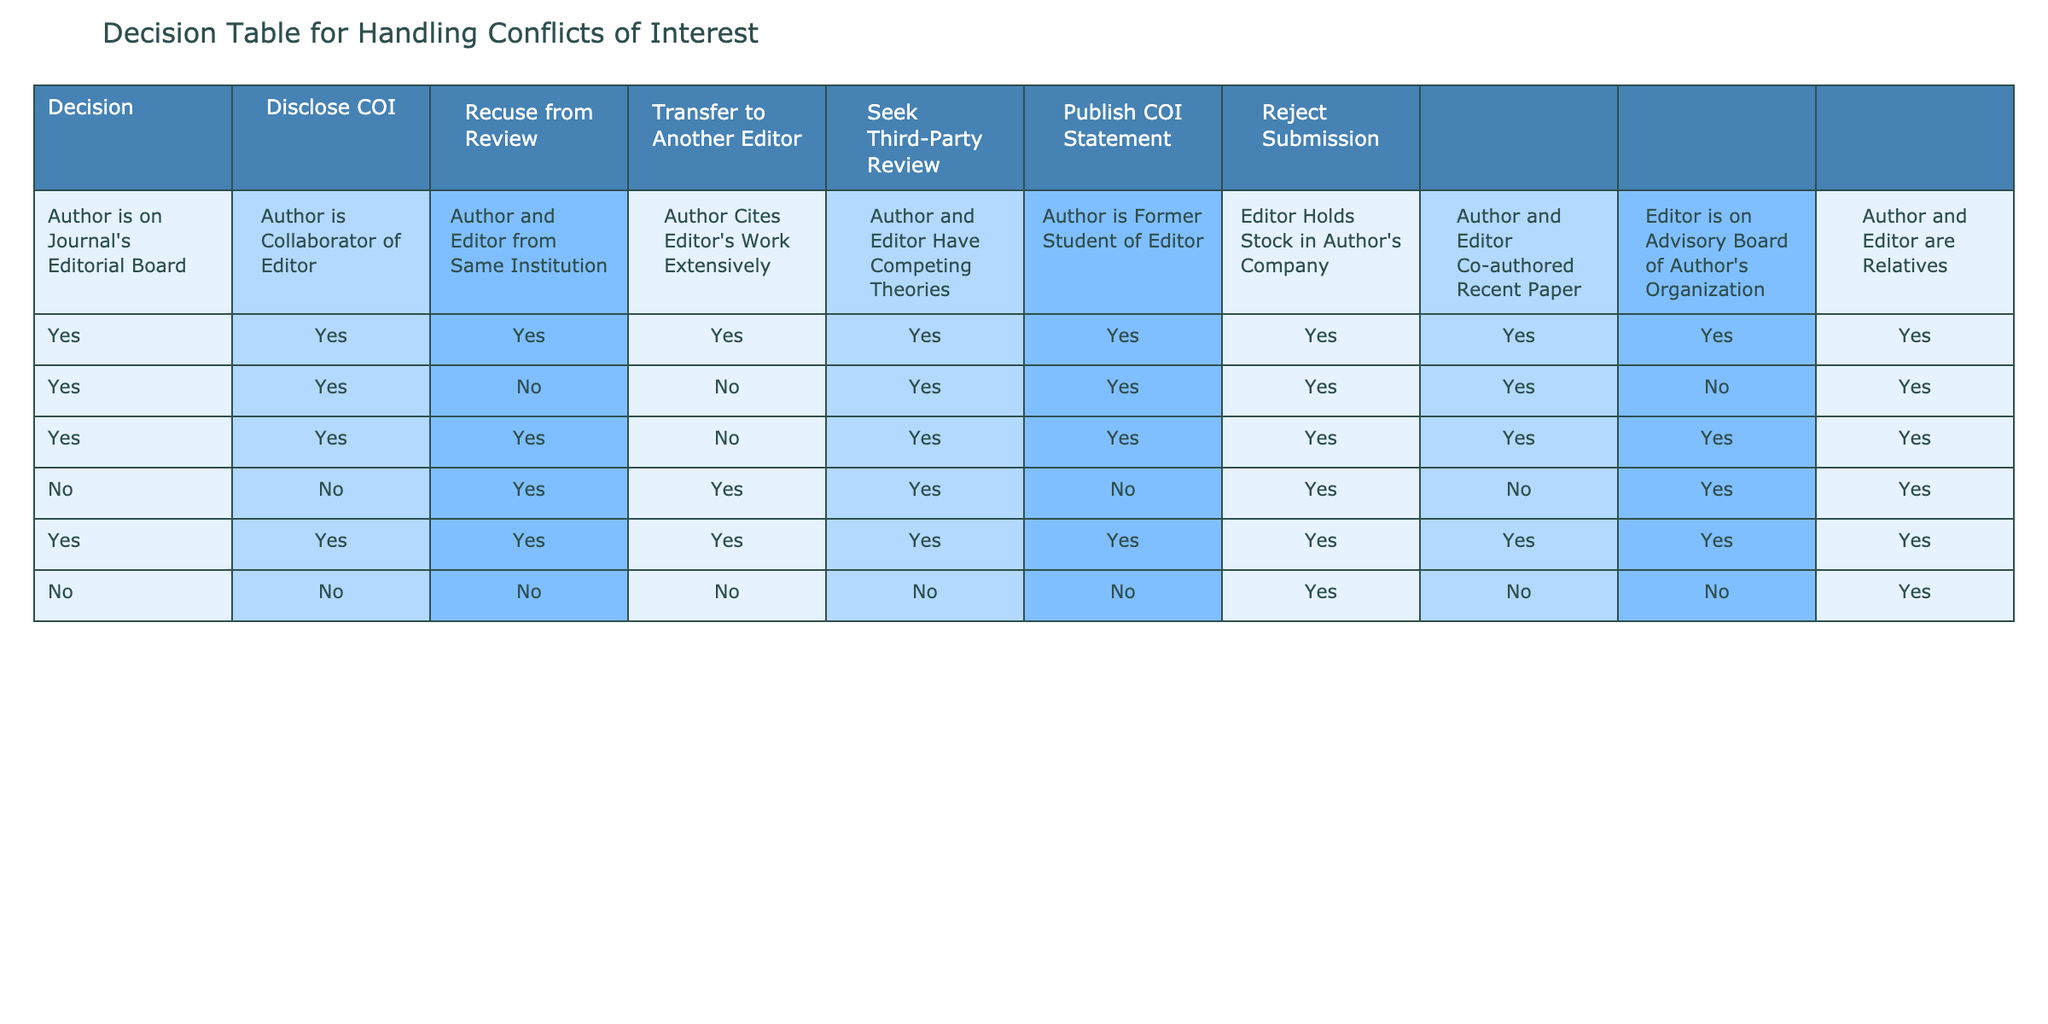What are the actions taken when an author is on the journal's editorial board? According to the table, when an author is on the journal's editorial board, the actions are to disclose the conflict of interest, recuse from review, transfer to another editor, seek third-party review, publish a conflict of interest statement, and reject the submission. This results in a 'Yes' for all actions except for rejection.
Answer: Yes, Yes, Yes, No, Yes, No Is it necessary to disclose a conflict of interest when the author and editor are from the same institution? Yes, the table indicates that it is necessary to disclose the conflict of interest in this scenario as it states 'Yes' under the "Disclose COI" column.
Answer: Yes In how many situations is it advised to seek a third-party review? The table shows that seeking a third-party review is advised in 4 situations: when the author and editor have competing theories, when the author and editor are related, when the author is a collaborator of the editor, and when the author cites the editor's work extensively. This is computed by counting 'Yes' responses in the third-party review column.
Answer: 4 If an author and an editor have competing theories, what actions can be taken? When an author and editor have competing theories, the table indicates that the following actions are recommended: disclose conflict of interest (Yes), recuse from review (Yes), transfer to another editor (Yes), seek third-party review (Yes), publish a COI statement (Yes), and reject the submission (No). This requires looking at that specific row in the table for decisions.
Answer: Yes, Yes, Yes, Yes, Yes, No Does holding stock in the author's company warrant rejecting the submission? Yes, in the case where an editor holds stock in the author's company, the submission would be rejected, which is indicated by a 'Yes' in the "Reject Submission" column.
Answer: Yes 